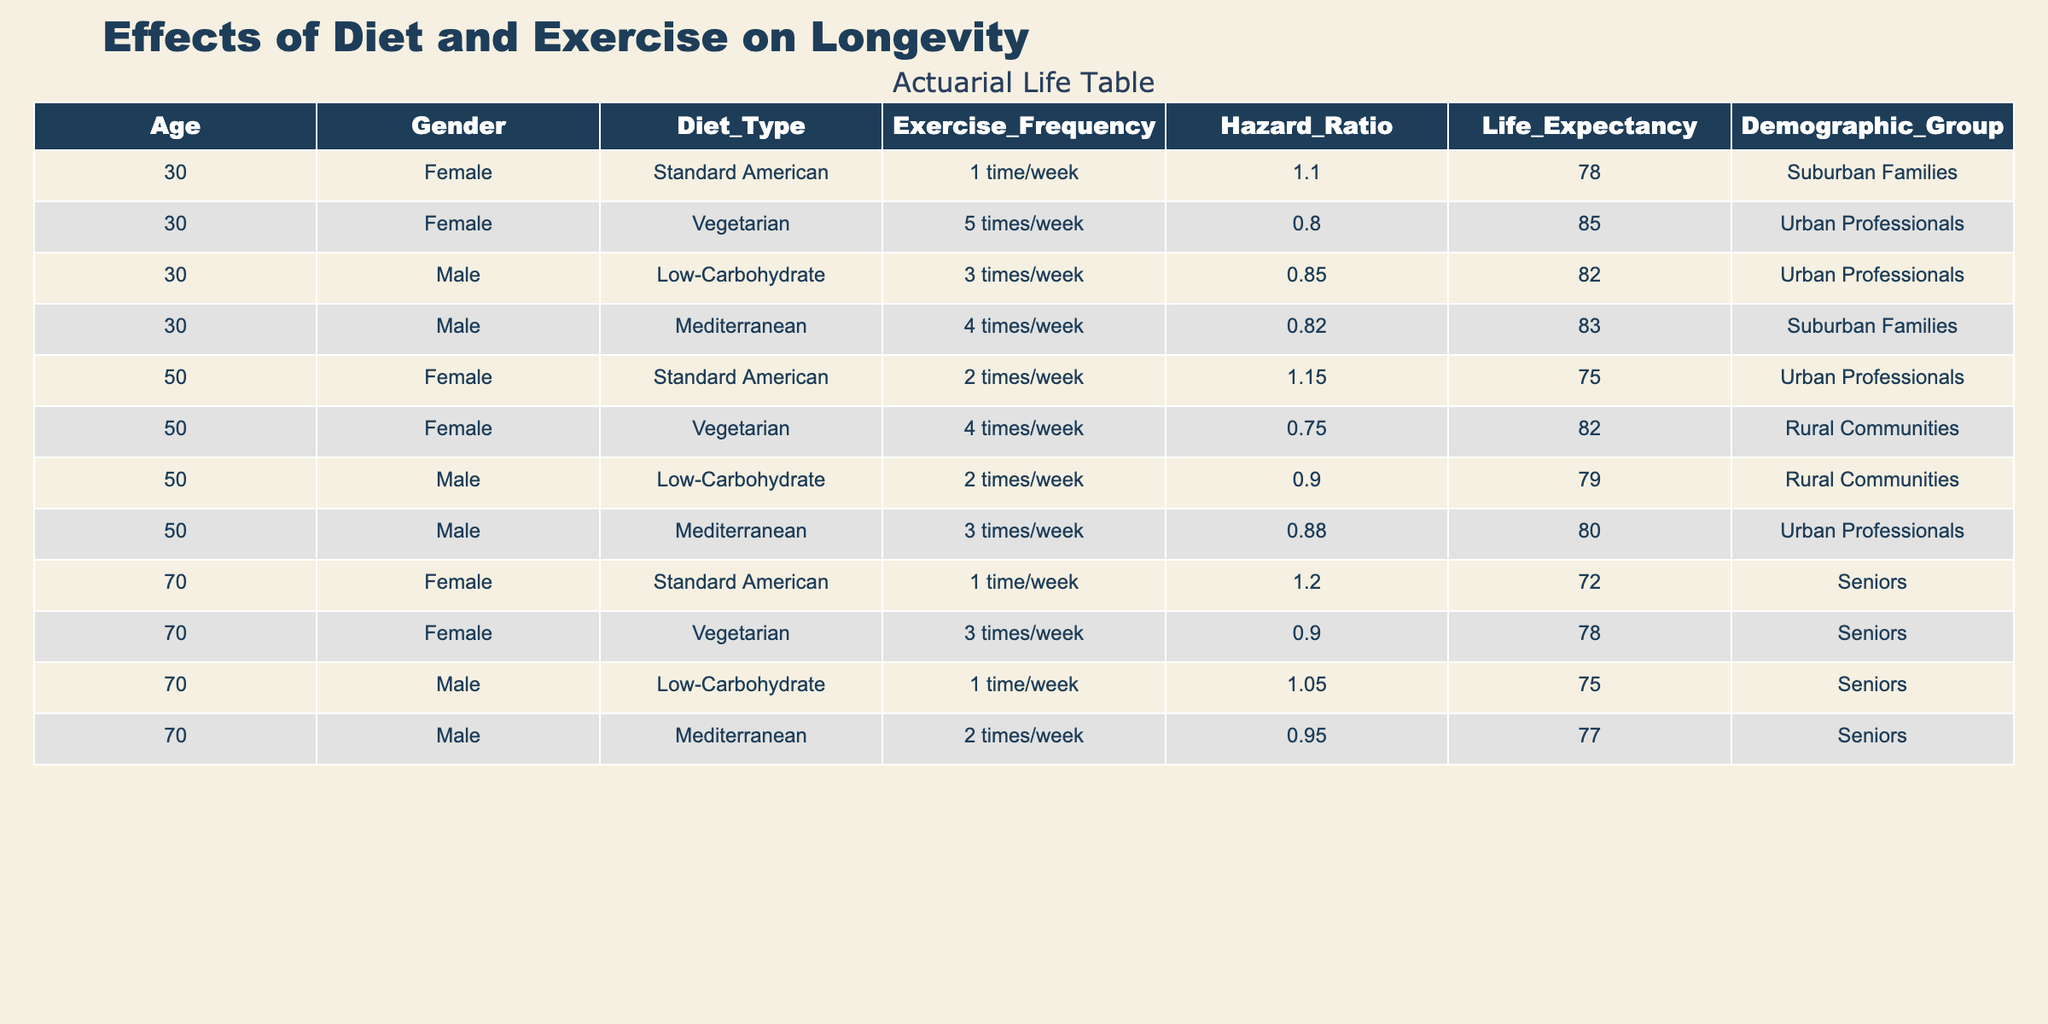What is the life expectancy for 50-year-old females who follow a vegetarian diet? In the table, you find the row for a 50-year-old female with a vegetarian diet. The life expectancy listed for this demographic is 82.
Answer: 82 Which demographic group tends to have a higher life expectancy, Urban Professionals or Rural Communities? By comparing the life expectancies, Urban Professionals have values of 82 (30-year-old male), 85 (30-year-old female), and 80 (50-year-old male), giving an average of (82 + 85 + 80) / 3 = 82.33. Rural Communities have life expectancies of 79 (50-year-old male) and 82 (50-year-old female), which average (79 + 82) / 2 = 80.5. Urban Professionals have a higher average life expectancy.
Answer: Urban Professionals Is the hazard ratio for 30-year-old males following a standard American diet less than 1? In the table, the row for a 30-year-old male on a standard American diet shows a hazard ratio of 1.10, which is greater than 1.
Answer: No What is the difference in life expectancy between 70-year-old males following a low-carbohydrate diet and those following a vegetarian diet? The life expectancy for 70-year-old males on a low-carbohydrate diet is 75, while on a vegetarian diet, it's 78. The difference is calculated as 78 - 75 = 3 years.
Answer: 3 years How does the exercise frequency correlate with the life expectancy of 30-year-old males in various diet types? Analyzing the table, 30-year-old males have different exercise frequencies and corresponding life expectancies: Low-Carbohydrate (3 times/week) has 82, Mediterranean (4 times/week) has 83, and Standard American (1 time/week) has 78. Higher exercise frequency generally correlates with higher life expectancy in this data set.
Answer: Higher exercise frequency correlates with higher life expectancy 